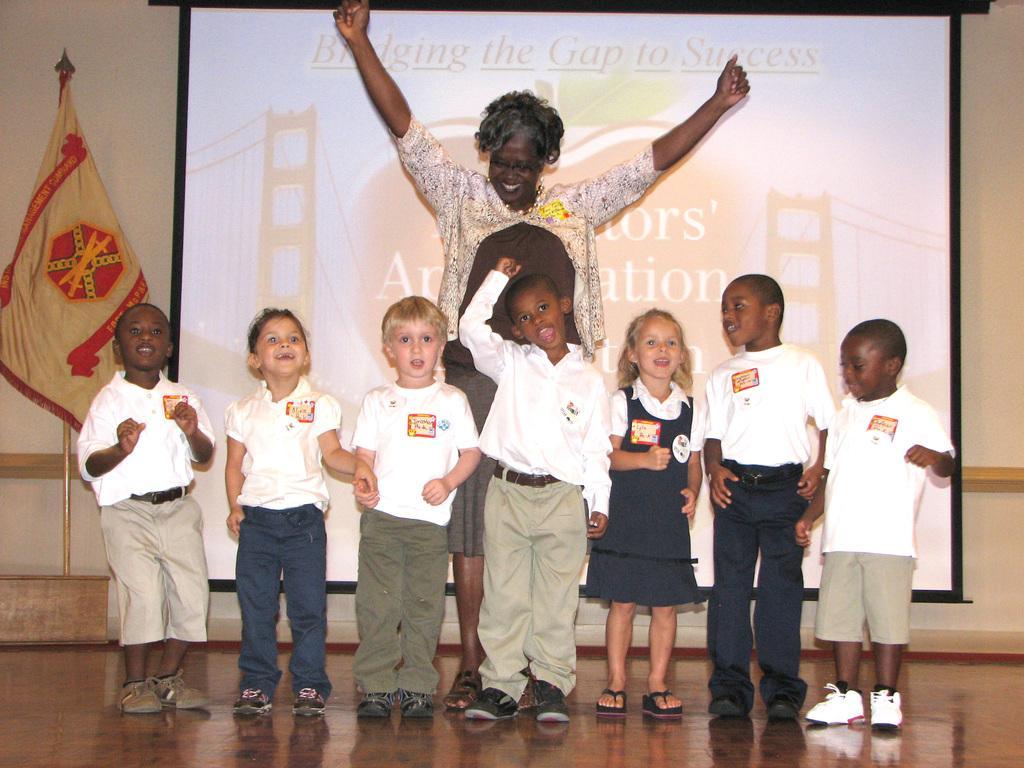In one or two sentences, can you explain what this image depicts? There are a group of children's and a woman standing and smiling. This is a flag hanging to a pole. This looks like a screen with a display. I think this is the floor. In the background, I can see the wall. 